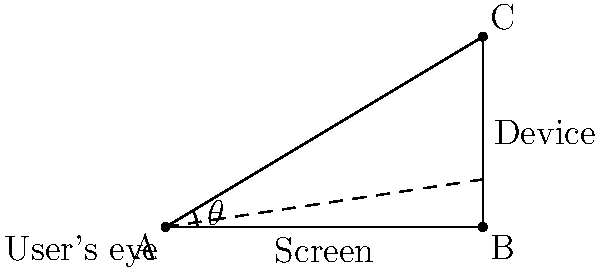As a project manager working with a web developer, you need to ensure optimal website visibility across different devices. The developer informs you that for a particular device, the screen is 10 inches wide and positioned 6 inches above the user's eye level. What is the angle of elevation ($\theta$) from the user's eye to the top of the screen, rounded to the nearest degree? To solve this problem, we'll use trigonometry. Let's break it down step-by-step:

1. Identify the triangle: We have a right-angled triangle formed by the user's eye (A), the bottom of the screen (B), and the top of the screen (C).

2. Identify the sides:
   - Adjacent side (AB) = 10 inches (width of the screen)
   - Opposite side (BC) = 6 inches (height of the screen above eye level)

3. We need to find the angle of elevation ($\theta$), which is the angle formed at the user's eye (A).

4. The trigonometric function that relates the opposite side to the adjacent side is tangent:

   $\tan(\theta) = \frac{\text{opposite}}{\text{adjacent}} = \frac{BC}{AB}$

5. Substitute the values:

   $\tan(\theta) = \frac{6}{10} = 0.6$

6. To find $\theta$, we need to use the inverse tangent (arctangent) function:

   $\theta = \arctan(0.6)$

7. Calculate using a calculator or programming language:

   $\theta \approx 30.96375653207352$ degrees

8. Rounding to the nearest degree:

   $\theta \approx 31$ degrees
Answer: 31 degrees 